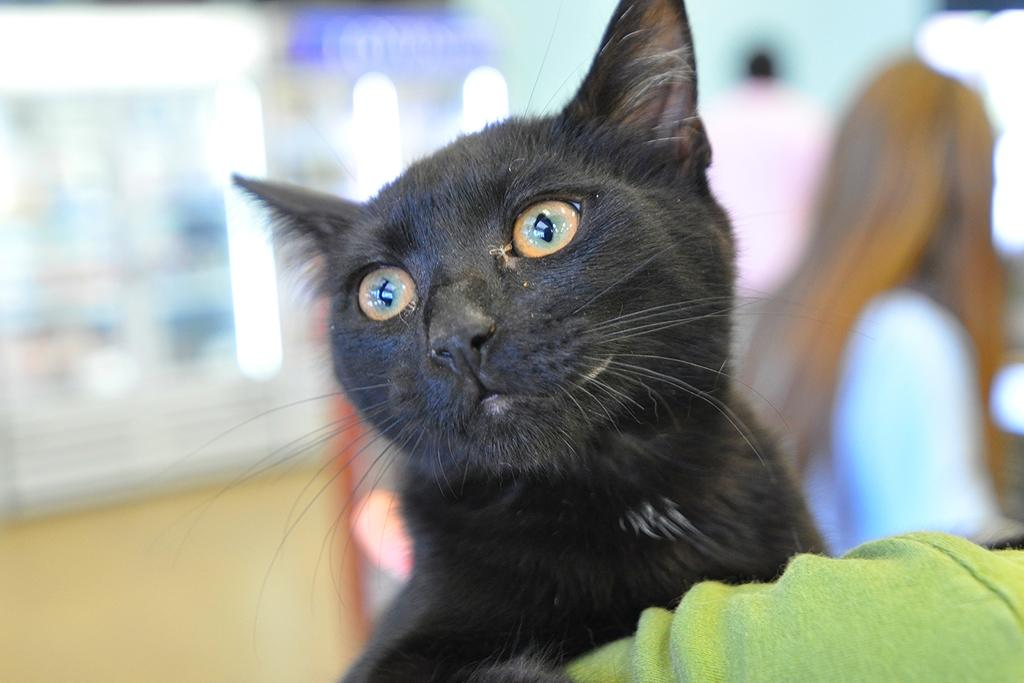What type of animal is in the image? There is a cat in the image. What else can be seen in the image besides the cat? There is a cloth in the image. Can you describe the background of the image? The background of the image is blurred. What day of the week is depicted in the image? The image does not depict a specific day of the week. Does the existence of the cat in the image prove the existence of all cats in the world? The presence of the cat in the image does not prove the existence of all cats in the world; it only shows one particular cat. 